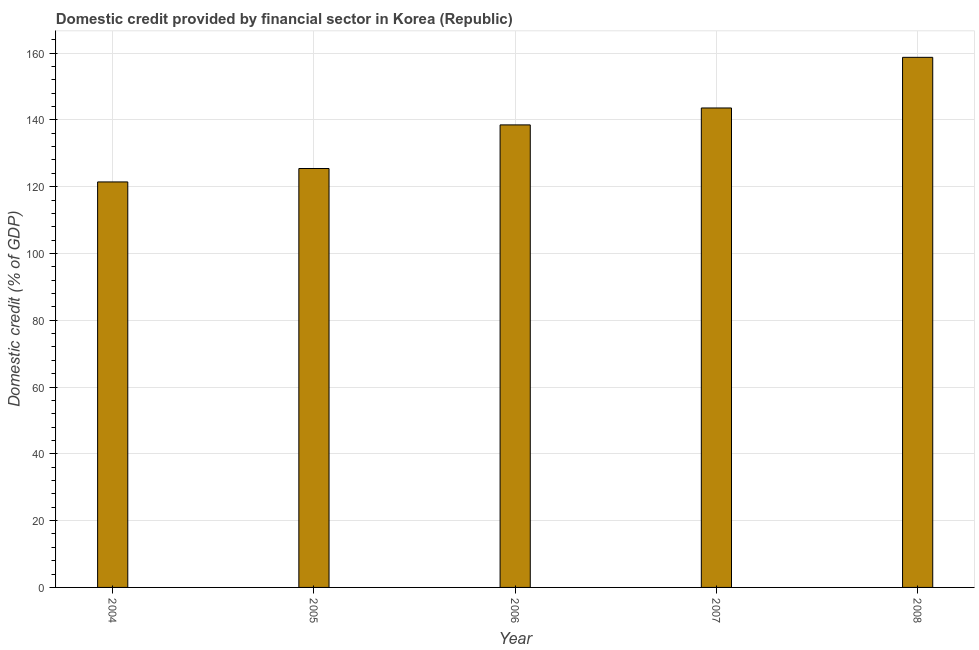What is the title of the graph?
Your answer should be compact. Domestic credit provided by financial sector in Korea (Republic). What is the label or title of the X-axis?
Your response must be concise. Year. What is the label or title of the Y-axis?
Offer a very short reply. Domestic credit (% of GDP). What is the domestic credit provided by financial sector in 2008?
Keep it short and to the point. 158.75. Across all years, what is the maximum domestic credit provided by financial sector?
Your answer should be very brief. 158.75. Across all years, what is the minimum domestic credit provided by financial sector?
Keep it short and to the point. 121.43. In which year was the domestic credit provided by financial sector minimum?
Provide a short and direct response. 2004. What is the sum of the domestic credit provided by financial sector?
Keep it short and to the point. 687.72. What is the difference between the domestic credit provided by financial sector in 2004 and 2008?
Provide a succinct answer. -37.31. What is the average domestic credit provided by financial sector per year?
Your answer should be very brief. 137.54. What is the median domestic credit provided by financial sector?
Offer a very short reply. 138.51. In how many years, is the domestic credit provided by financial sector greater than 160 %?
Provide a succinct answer. 0. Do a majority of the years between 2008 and 2006 (inclusive) have domestic credit provided by financial sector greater than 136 %?
Make the answer very short. Yes. What is the ratio of the domestic credit provided by financial sector in 2005 to that in 2007?
Make the answer very short. 0.87. Is the difference between the domestic credit provided by financial sector in 2007 and 2008 greater than the difference between any two years?
Offer a terse response. No. What is the difference between the highest and the second highest domestic credit provided by financial sector?
Your answer should be compact. 15.17. Is the sum of the domestic credit provided by financial sector in 2005 and 2007 greater than the maximum domestic credit provided by financial sector across all years?
Your response must be concise. Yes. What is the difference between the highest and the lowest domestic credit provided by financial sector?
Your response must be concise. 37.31. In how many years, is the domestic credit provided by financial sector greater than the average domestic credit provided by financial sector taken over all years?
Your answer should be compact. 3. How many bars are there?
Your answer should be very brief. 5. How many years are there in the graph?
Your answer should be very brief. 5. What is the difference between two consecutive major ticks on the Y-axis?
Your response must be concise. 20. Are the values on the major ticks of Y-axis written in scientific E-notation?
Make the answer very short. No. What is the Domestic credit (% of GDP) in 2004?
Your response must be concise. 121.43. What is the Domestic credit (% of GDP) of 2005?
Offer a very short reply. 125.45. What is the Domestic credit (% of GDP) of 2006?
Offer a terse response. 138.51. What is the Domestic credit (% of GDP) of 2007?
Give a very brief answer. 143.58. What is the Domestic credit (% of GDP) in 2008?
Ensure brevity in your answer.  158.75. What is the difference between the Domestic credit (% of GDP) in 2004 and 2005?
Offer a very short reply. -4.02. What is the difference between the Domestic credit (% of GDP) in 2004 and 2006?
Keep it short and to the point. -17.08. What is the difference between the Domestic credit (% of GDP) in 2004 and 2007?
Keep it short and to the point. -22.15. What is the difference between the Domestic credit (% of GDP) in 2004 and 2008?
Offer a very short reply. -37.31. What is the difference between the Domestic credit (% of GDP) in 2005 and 2006?
Your answer should be very brief. -13.06. What is the difference between the Domestic credit (% of GDP) in 2005 and 2007?
Give a very brief answer. -18.13. What is the difference between the Domestic credit (% of GDP) in 2005 and 2008?
Offer a terse response. -33.29. What is the difference between the Domestic credit (% of GDP) in 2006 and 2007?
Offer a terse response. -5.07. What is the difference between the Domestic credit (% of GDP) in 2006 and 2008?
Give a very brief answer. -20.23. What is the difference between the Domestic credit (% of GDP) in 2007 and 2008?
Your answer should be compact. -15.17. What is the ratio of the Domestic credit (% of GDP) in 2004 to that in 2005?
Give a very brief answer. 0.97. What is the ratio of the Domestic credit (% of GDP) in 2004 to that in 2006?
Your response must be concise. 0.88. What is the ratio of the Domestic credit (% of GDP) in 2004 to that in 2007?
Give a very brief answer. 0.85. What is the ratio of the Domestic credit (% of GDP) in 2004 to that in 2008?
Your answer should be very brief. 0.77. What is the ratio of the Domestic credit (% of GDP) in 2005 to that in 2006?
Your answer should be very brief. 0.91. What is the ratio of the Domestic credit (% of GDP) in 2005 to that in 2007?
Your answer should be very brief. 0.87. What is the ratio of the Domestic credit (% of GDP) in 2005 to that in 2008?
Offer a terse response. 0.79. What is the ratio of the Domestic credit (% of GDP) in 2006 to that in 2008?
Your answer should be compact. 0.87. What is the ratio of the Domestic credit (% of GDP) in 2007 to that in 2008?
Your response must be concise. 0.9. 